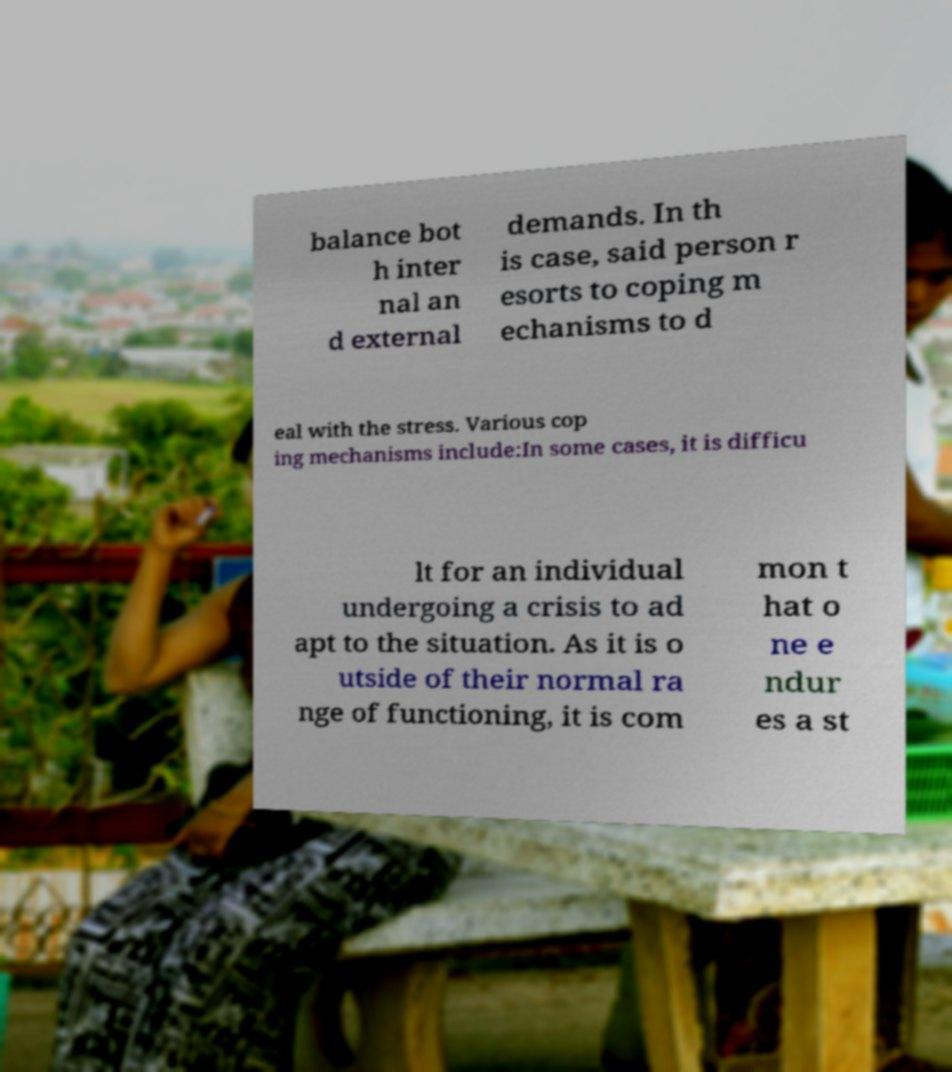Can you accurately transcribe the text from the provided image for me? balance bot h inter nal an d external demands. In th is case, said person r esorts to coping m echanisms to d eal with the stress. Various cop ing mechanisms include:In some cases, it is difficu lt for an individual undergoing a crisis to ad apt to the situation. As it is o utside of their normal ra nge of functioning, it is com mon t hat o ne e ndur es a st 